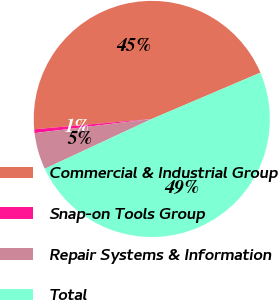Convert chart to OTSL. <chart><loc_0><loc_0><loc_500><loc_500><pie_chart><fcel>Commercial & Industrial Group<fcel>Snap-on Tools Group<fcel>Repair Systems & Information<fcel>Total<nl><fcel>44.98%<fcel>0.52%<fcel>5.02%<fcel>49.48%<nl></chart> 